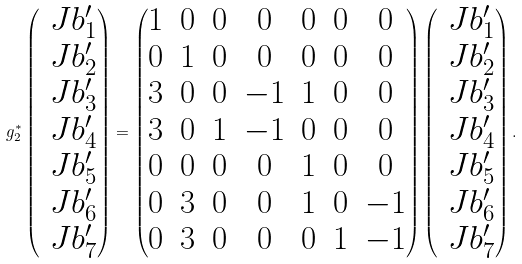Convert formula to latex. <formula><loc_0><loc_0><loc_500><loc_500>g _ { 2 } ^ { \ast } \begin{pmatrix} \ J b ^ { \prime } _ { 1 } \\ \ J b ^ { \prime } _ { 2 } \\ \ J b ^ { \prime } _ { 3 } \\ \ J b ^ { \prime } _ { 4 } \\ \ J b ^ { \prime } _ { 5 } \\ \ J b ^ { \prime } _ { 6 } \\ \ J b ^ { \prime } _ { 7 } \\ \end{pmatrix} = \begin{pmatrix} 1 & 0 & 0 & 0 & 0 & 0 & 0 \\ 0 & 1 & 0 & 0 & 0 & 0 & 0 \\ 3 & 0 & 0 & - 1 & 1 & 0 & 0 \\ 3 & 0 & 1 & - 1 & 0 & 0 & 0 \\ 0 & 0 & 0 & 0 & 1 & 0 & 0 \\ 0 & 3 & 0 & 0 & 1 & 0 & - 1 \\ 0 & 3 & 0 & 0 & 0 & 1 & - 1 \\ \end{pmatrix} \begin{pmatrix} \ J b ^ { \prime } _ { 1 } \\ \ J b ^ { \prime } _ { 2 } \\ \ J b ^ { \prime } _ { 3 } \\ \ J b ^ { \prime } _ { 4 } \\ \ J b ^ { \prime } _ { 5 } \\ \ J b ^ { \prime } _ { 6 } \\ \ J b ^ { \prime } _ { 7 } \\ \end{pmatrix} .</formula> 